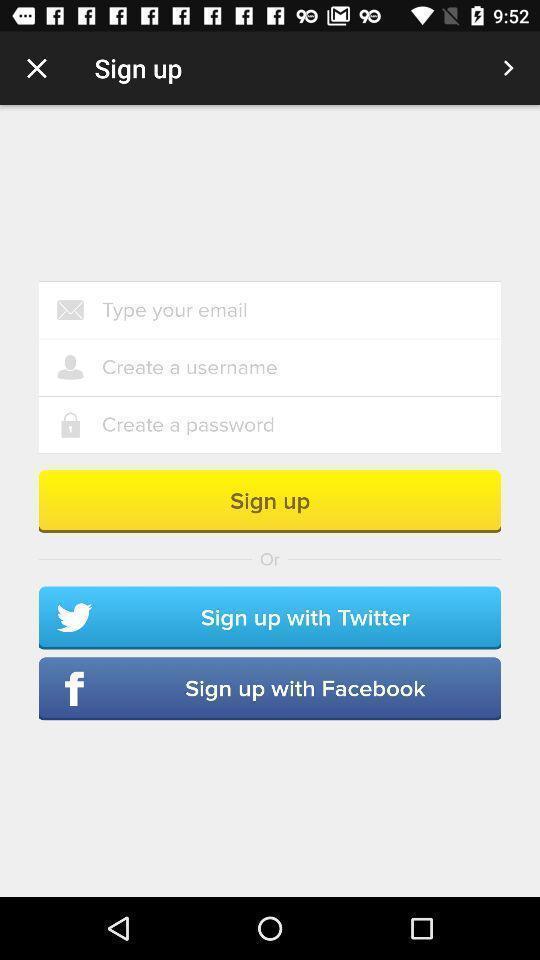Please provide a description for this image. Sign-up page of social app. 